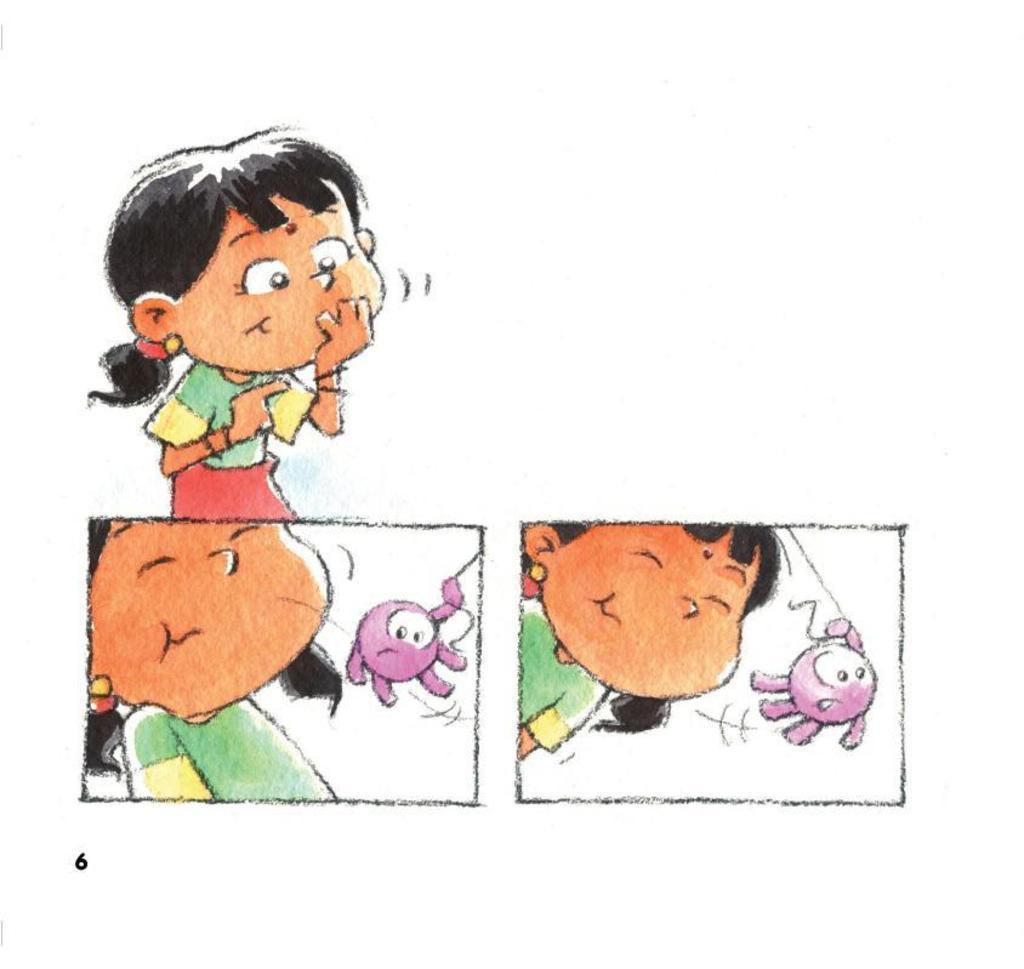Describe this image in one or two sentences. In this image we can see a drawing of a girl and in the bottom left corner we can see a number. 